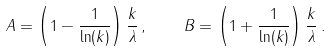Convert formula to latex. <formula><loc_0><loc_0><loc_500><loc_500>A = \left ( 1 - \frac { 1 } { \ln ( k ) } \right ) \frac { k } { \lambda } \, , \quad B = \left ( 1 + \frac { 1 } { \ln ( k ) } \right ) \frac { k } { \lambda } \, .</formula> 